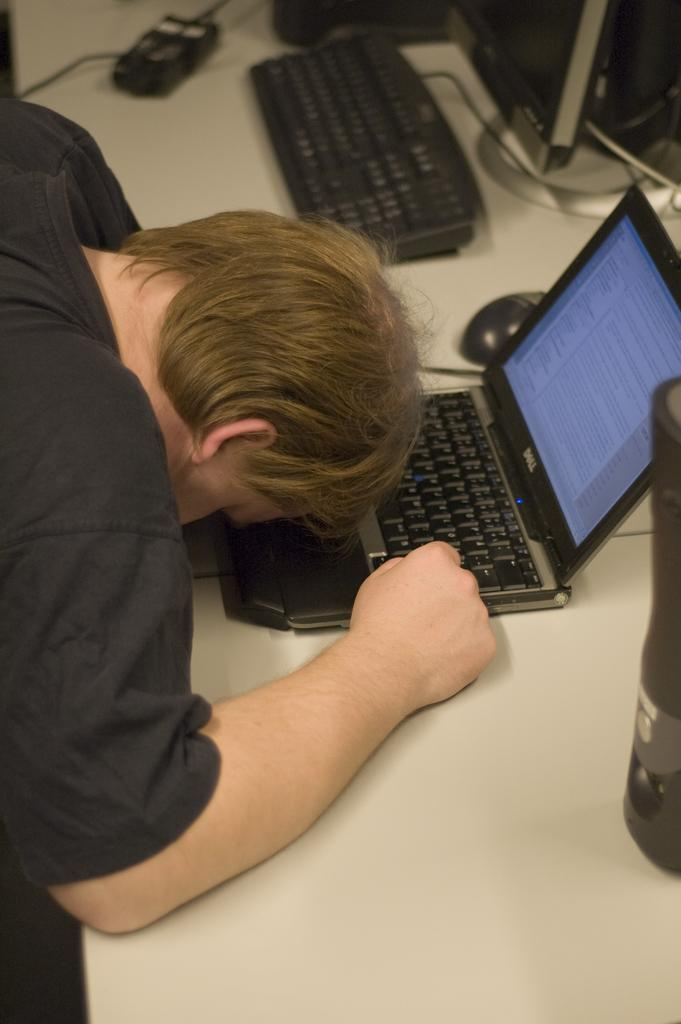Who is present in the image? There is a man in the image. What object can be seen in the image that is typically used for eating or working? There is a table in the image. What items are on the table in the image? There is a bottle, a laptop, a mouse, and a keyboard on the table. What type of zephyr can be seen blowing through the man's hair in the image? There is no zephyr present in the image, and the man's hair is not being blown by any wind. What type of prose is the man reading from the laptop in the image? The image does not show the man reading any prose, and there is no indication of what he might be doing on the laptop. 